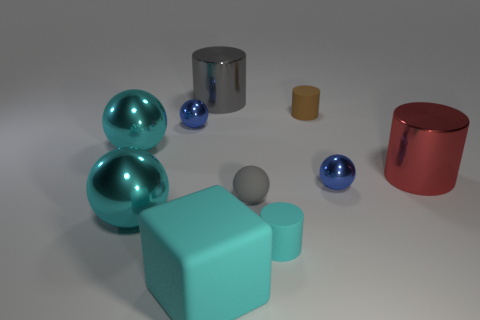The large cylinder that is the same material as the big red thing is what color? The large cylinder, which appears to share the same reflective, metallic material as the larger object with a red hue, is gray in color. 